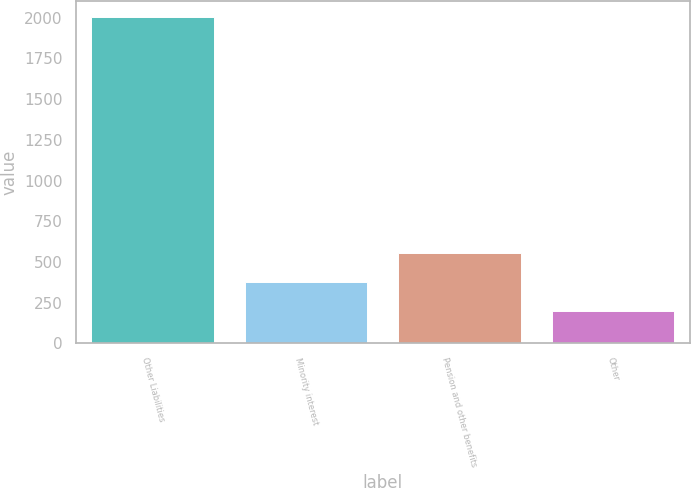Convert chart. <chart><loc_0><loc_0><loc_500><loc_500><bar_chart><fcel>Other Liabilities<fcel>Minority interest<fcel>Pension and other benefits<fcel>Other<nl><fcel>2002<fcel>376.51<fcel>557.12<fcel>195.9<nl></chart> 